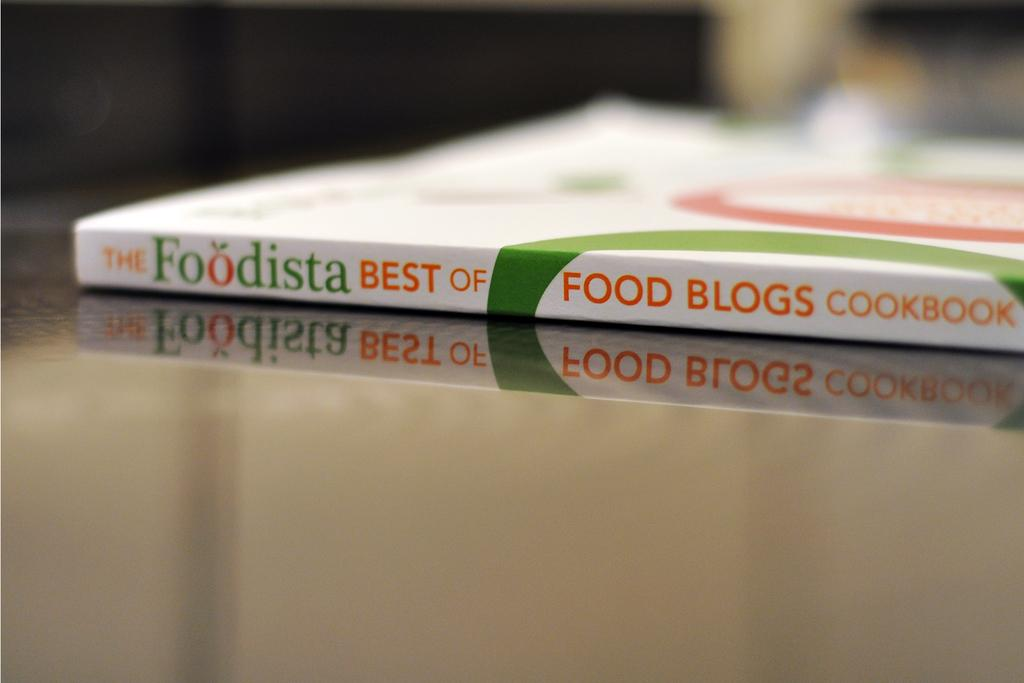<image>
Write a terse but informative summary of the picture. A food blogs cookbook is white, green, and orange. 